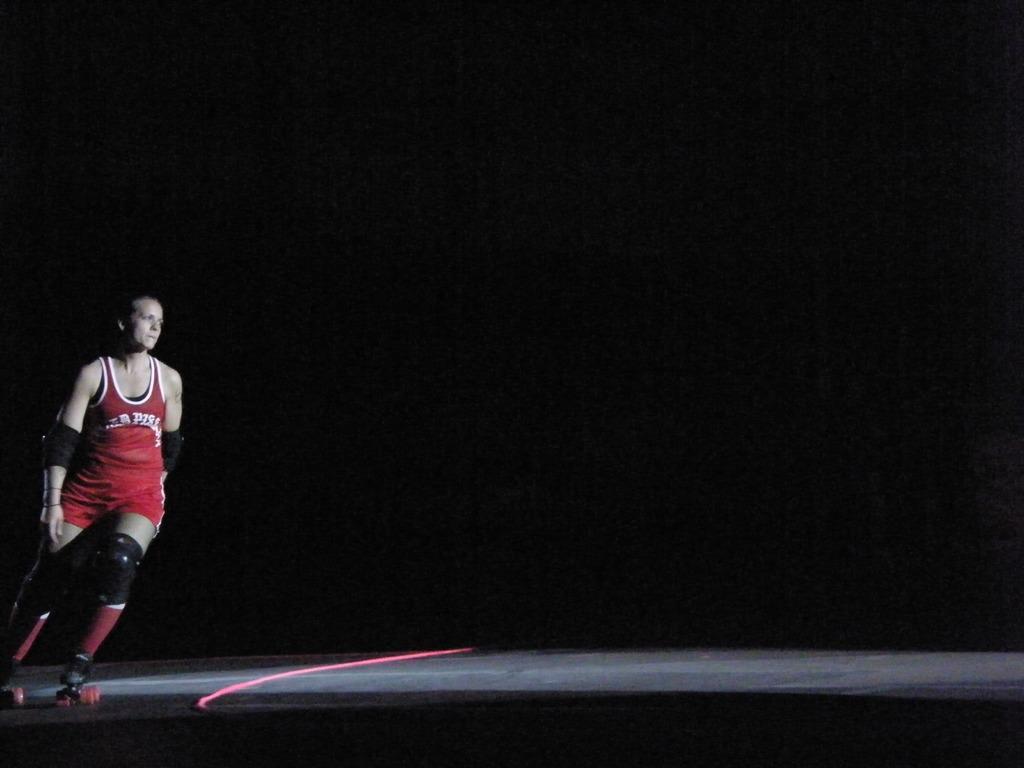Could you give a brief overview of what you see in this image? On the left side there is a person wearing knee pad and elbow pad is on a skateboard and skating. On the floor there is a red rope. In the background it is dark. 